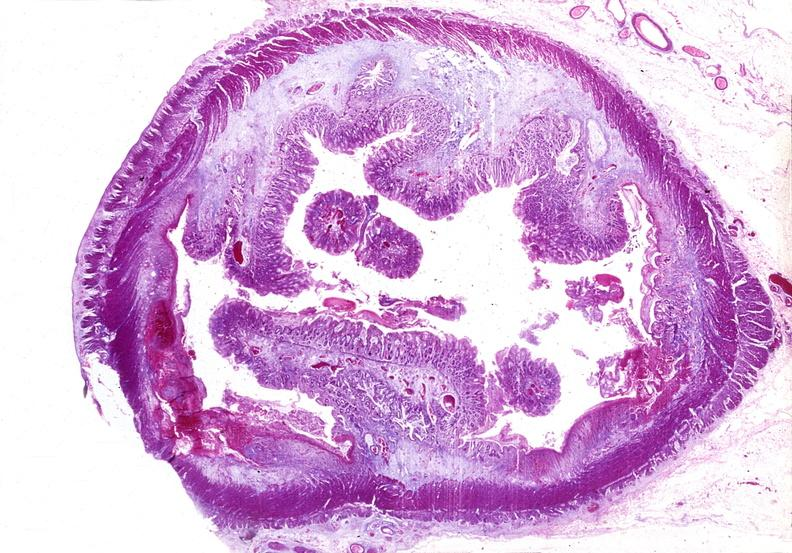where is this from?
Answer the question using a single word or phrase. Gastrointestinal system 